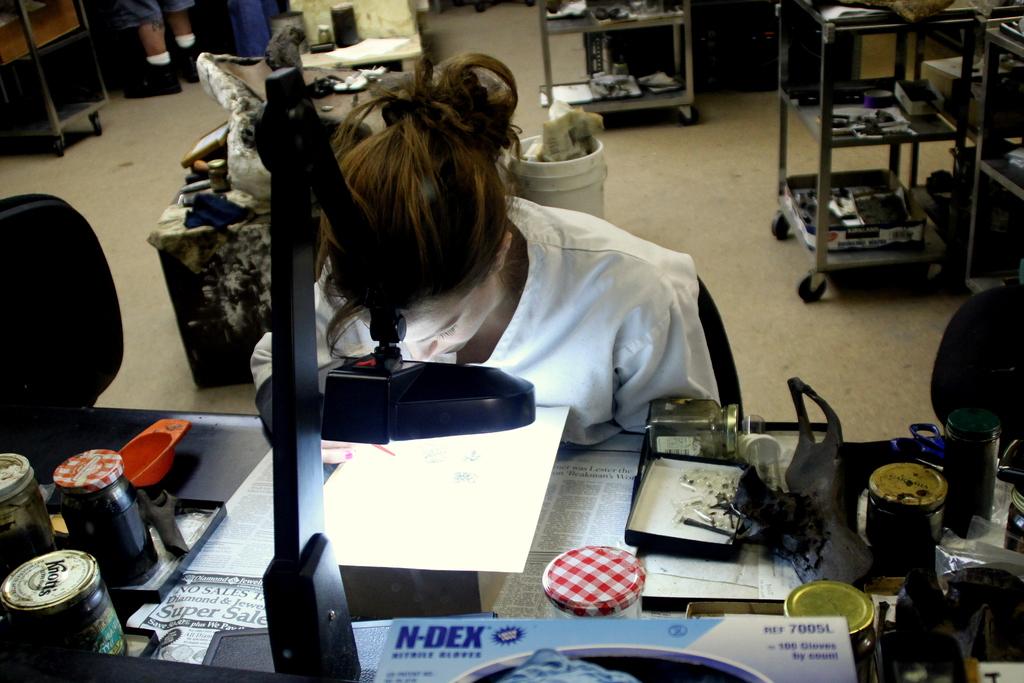What brand is labeled on the blue and white box?
Your answer should be very brief. N-dex. 